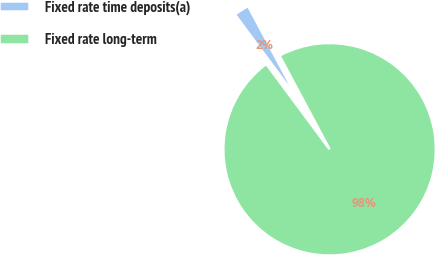<chart> <loc_0><loc_0><loc_500><loc_500><pie_chart><fcel>Fixed rate time deposits(a)<fcel>Fixed rate long-term<nl><fcel>2.35%<fcel>97.65%<nl></chart> 